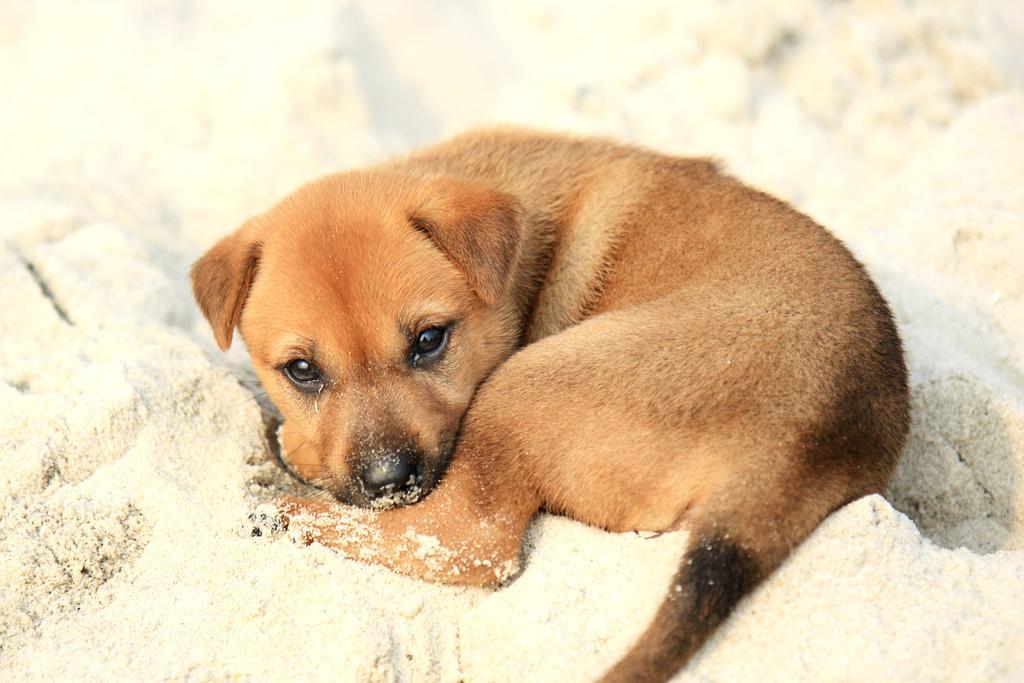Describe this image in one or two sentences. In this image we can see a dog on the sand. 